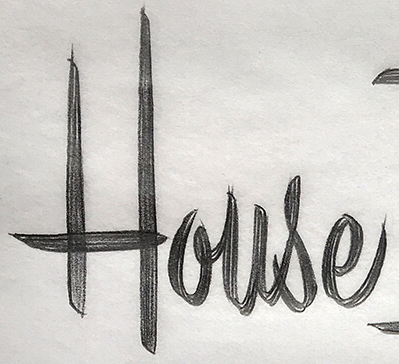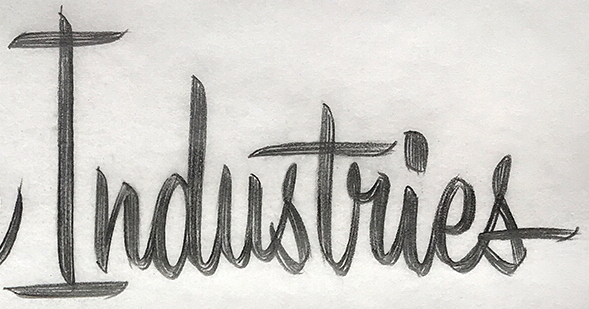Identify the words shown in these images in order, separated by a semicolon. House; Industries 